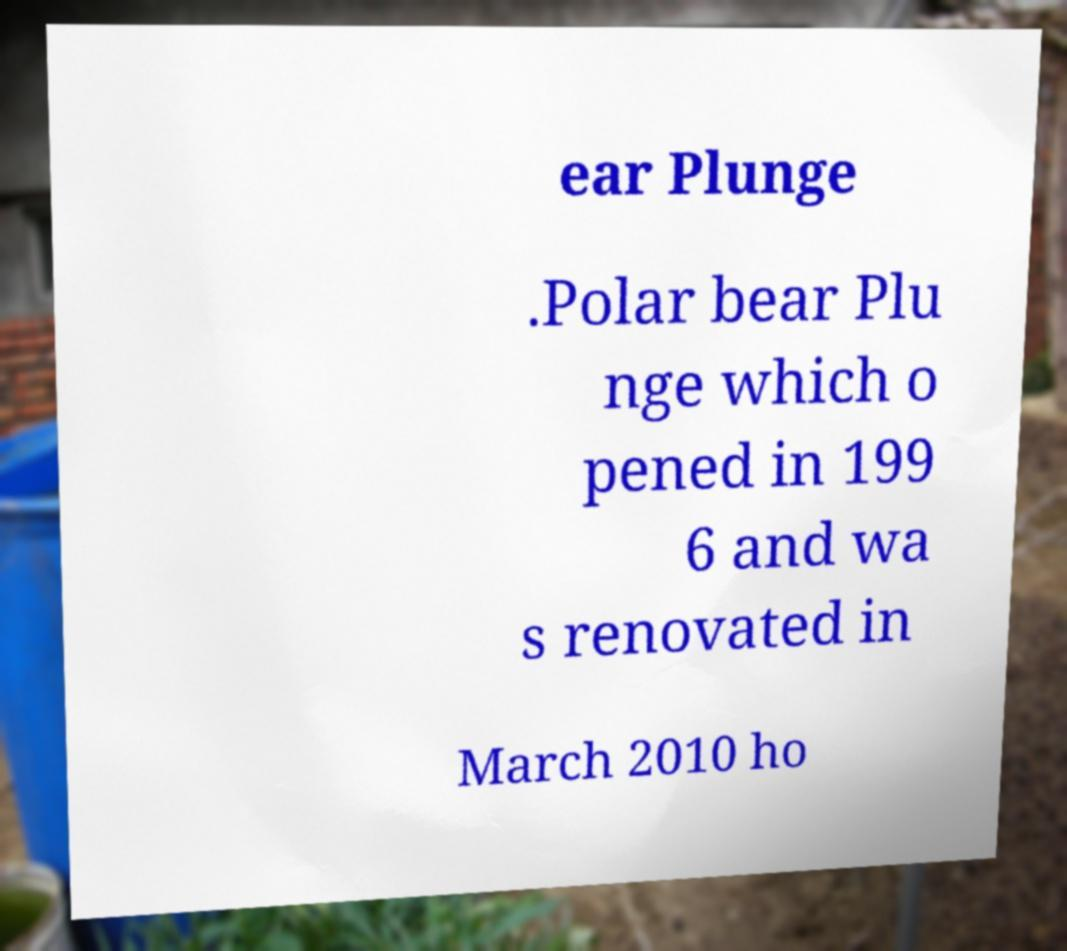Could you assist in decoding the text presented in this image and type it out clearly? ear Plunge .Polar bear Plu nge which o pened in 199 6 and wa s renovated in March 2010 ho 